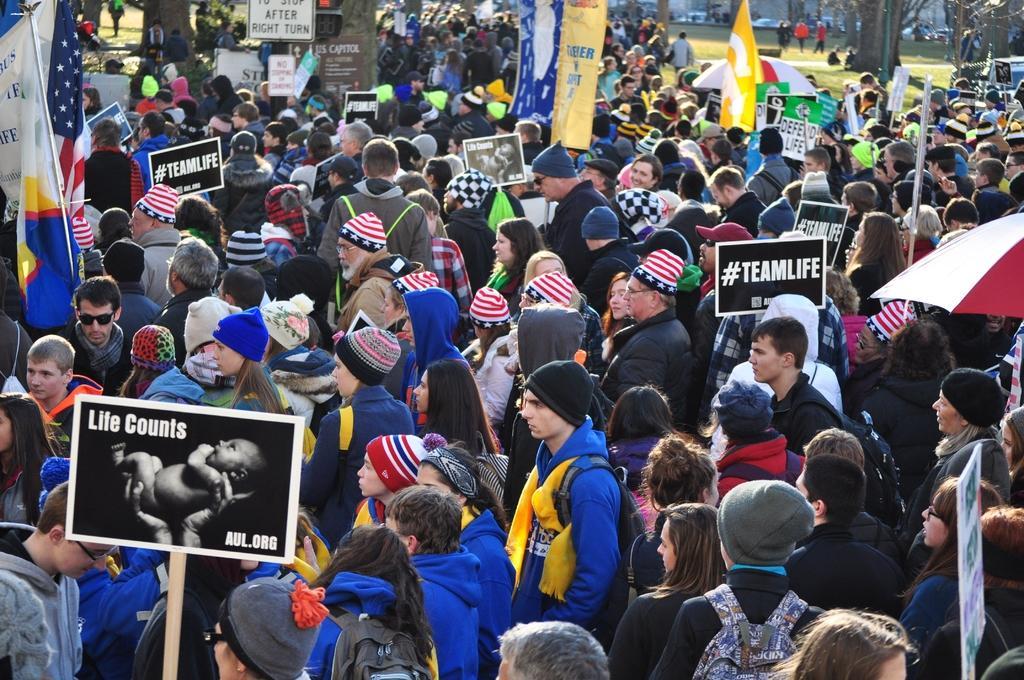How would you summarize this image in a sentence or two? In this image I can see the group of people with different color dresses. These people are wearing the caps. I can see the black color boards in-between these people. To the right I can see the umbrella. In the background I can see the flags, many banners and also trees. 